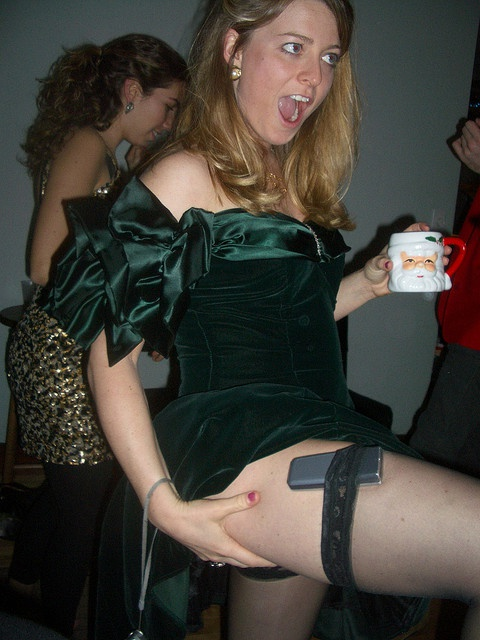Describe the objects in this image and their specific colors. I can see people in black, gray, tan, and darkgray tones, people in black, maroon, and gray tones, people in black and maroon tones, cup in black, lightgray, darkgray, maroon, and tan tones, and cell phone in black, gray, and purple tones in this image. 